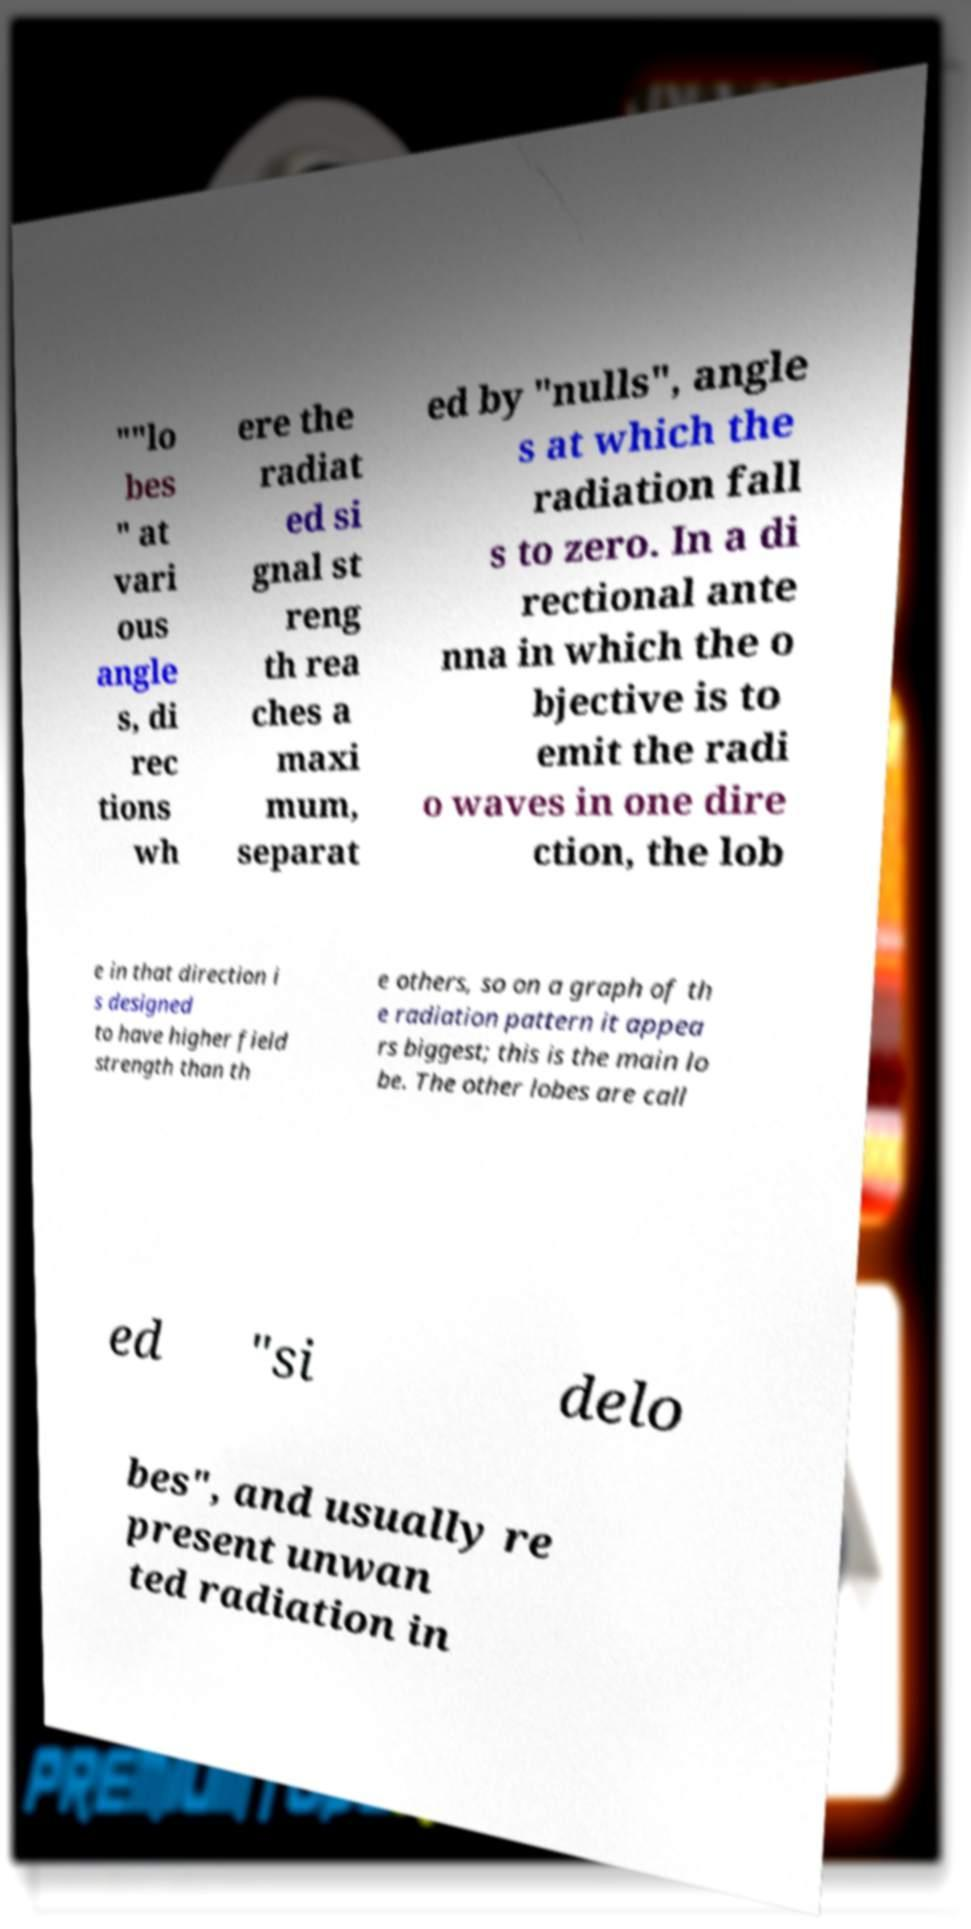What messages or text are displayed in this image? I need them in a readable, typed format. ""lo bes " at vari ous angle s, di rec tions wh ere the radiat ed si gnal st reng th rea ches a maxi mum, separat ed by "nulls", angle s at which the radiation fall s to zero. In a di rectional ante nna in which the o bjective is to emit the radi o waves in one dire ction, the lob e in that direction i s designed to have higher field strength than th e others, so on a graph of th e radiation pattern it appea rs biggest; this is the main lo be. The other lobes are call ed "si delo bes", and usually re present unwan ted radiation in 